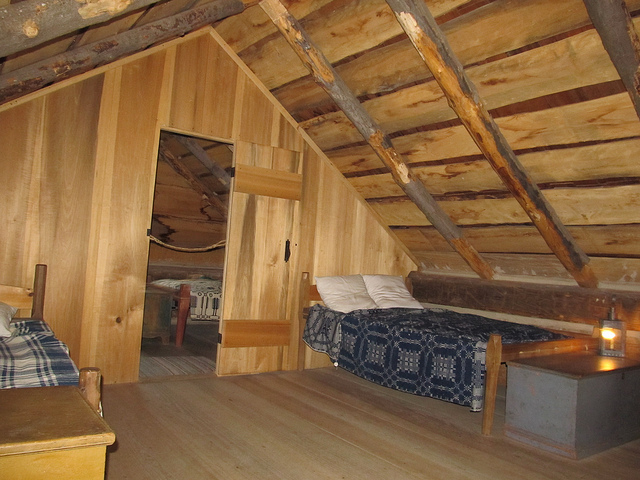How many beds can be seen? 2 